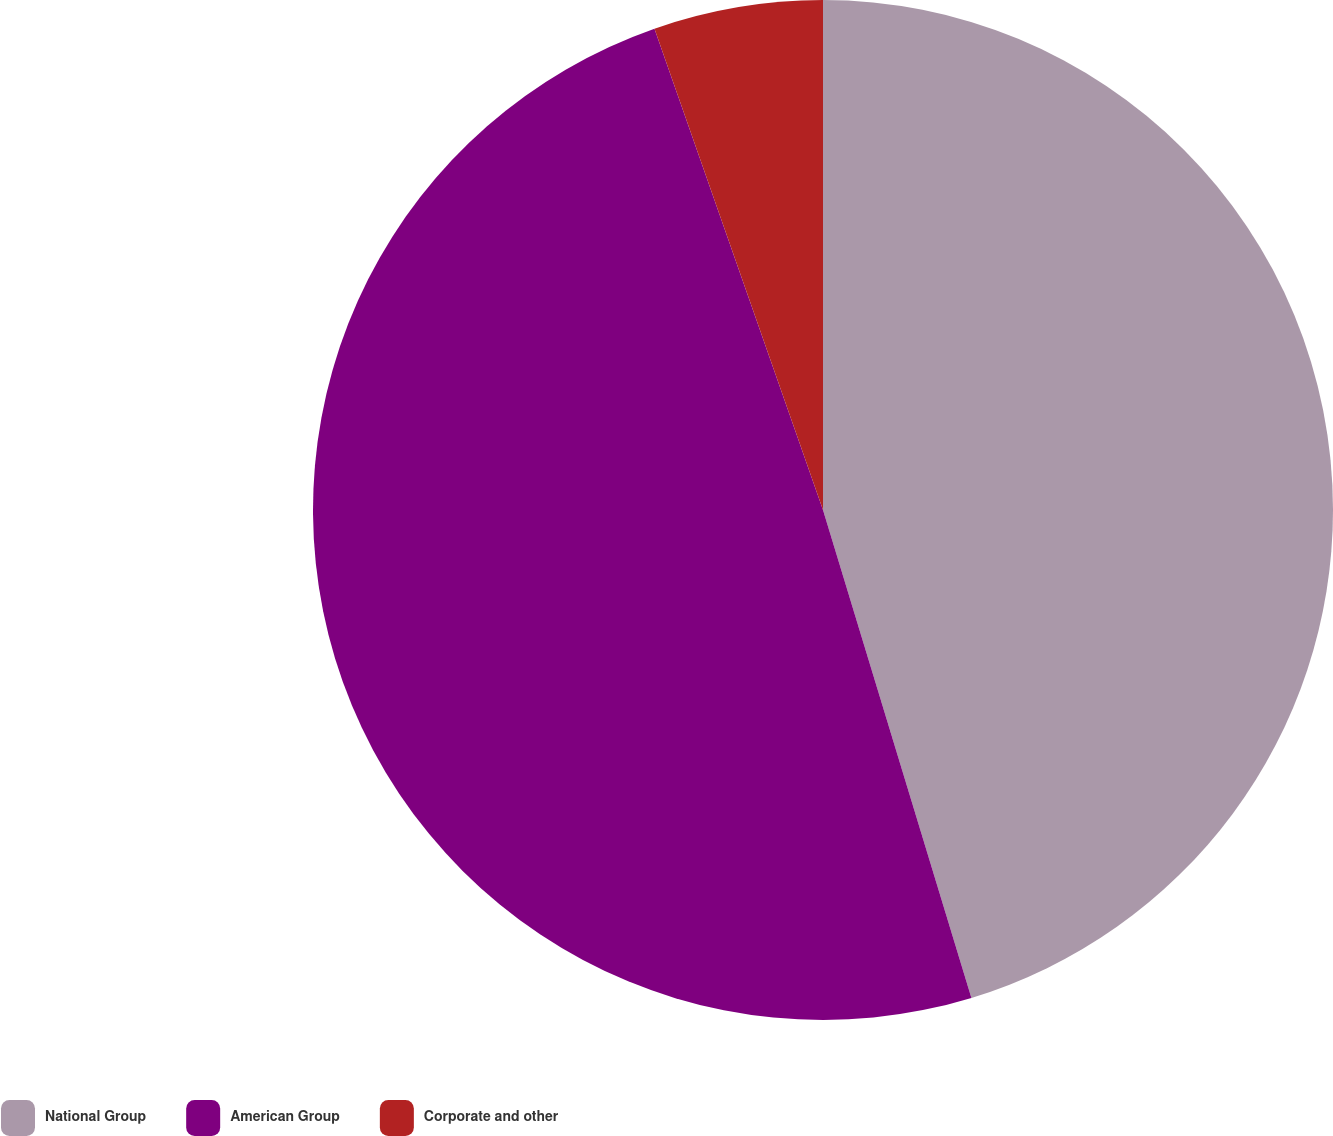<chart> <loc_0><loc_0><loc_500><loc_500><pie_chart><fcel>National Group<fcel>American Group<fcel>Corporate and other<nl><fcel>45.3%<fcel>49.34%<fcel>5.36%<nl></chart> 